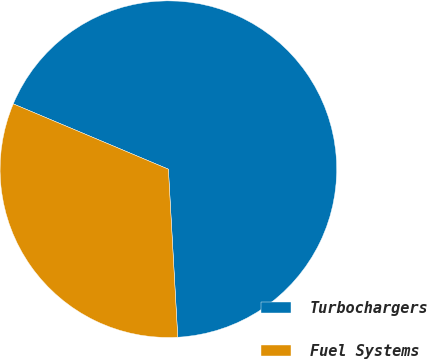<chart> <loc_0><loc_0><loc_500><loc_500><pie_chart><fcel>Turbochargers<fcel>Fuel Systems<nl><fcel>67.77%<fcel>32.23%<nl></chart> 